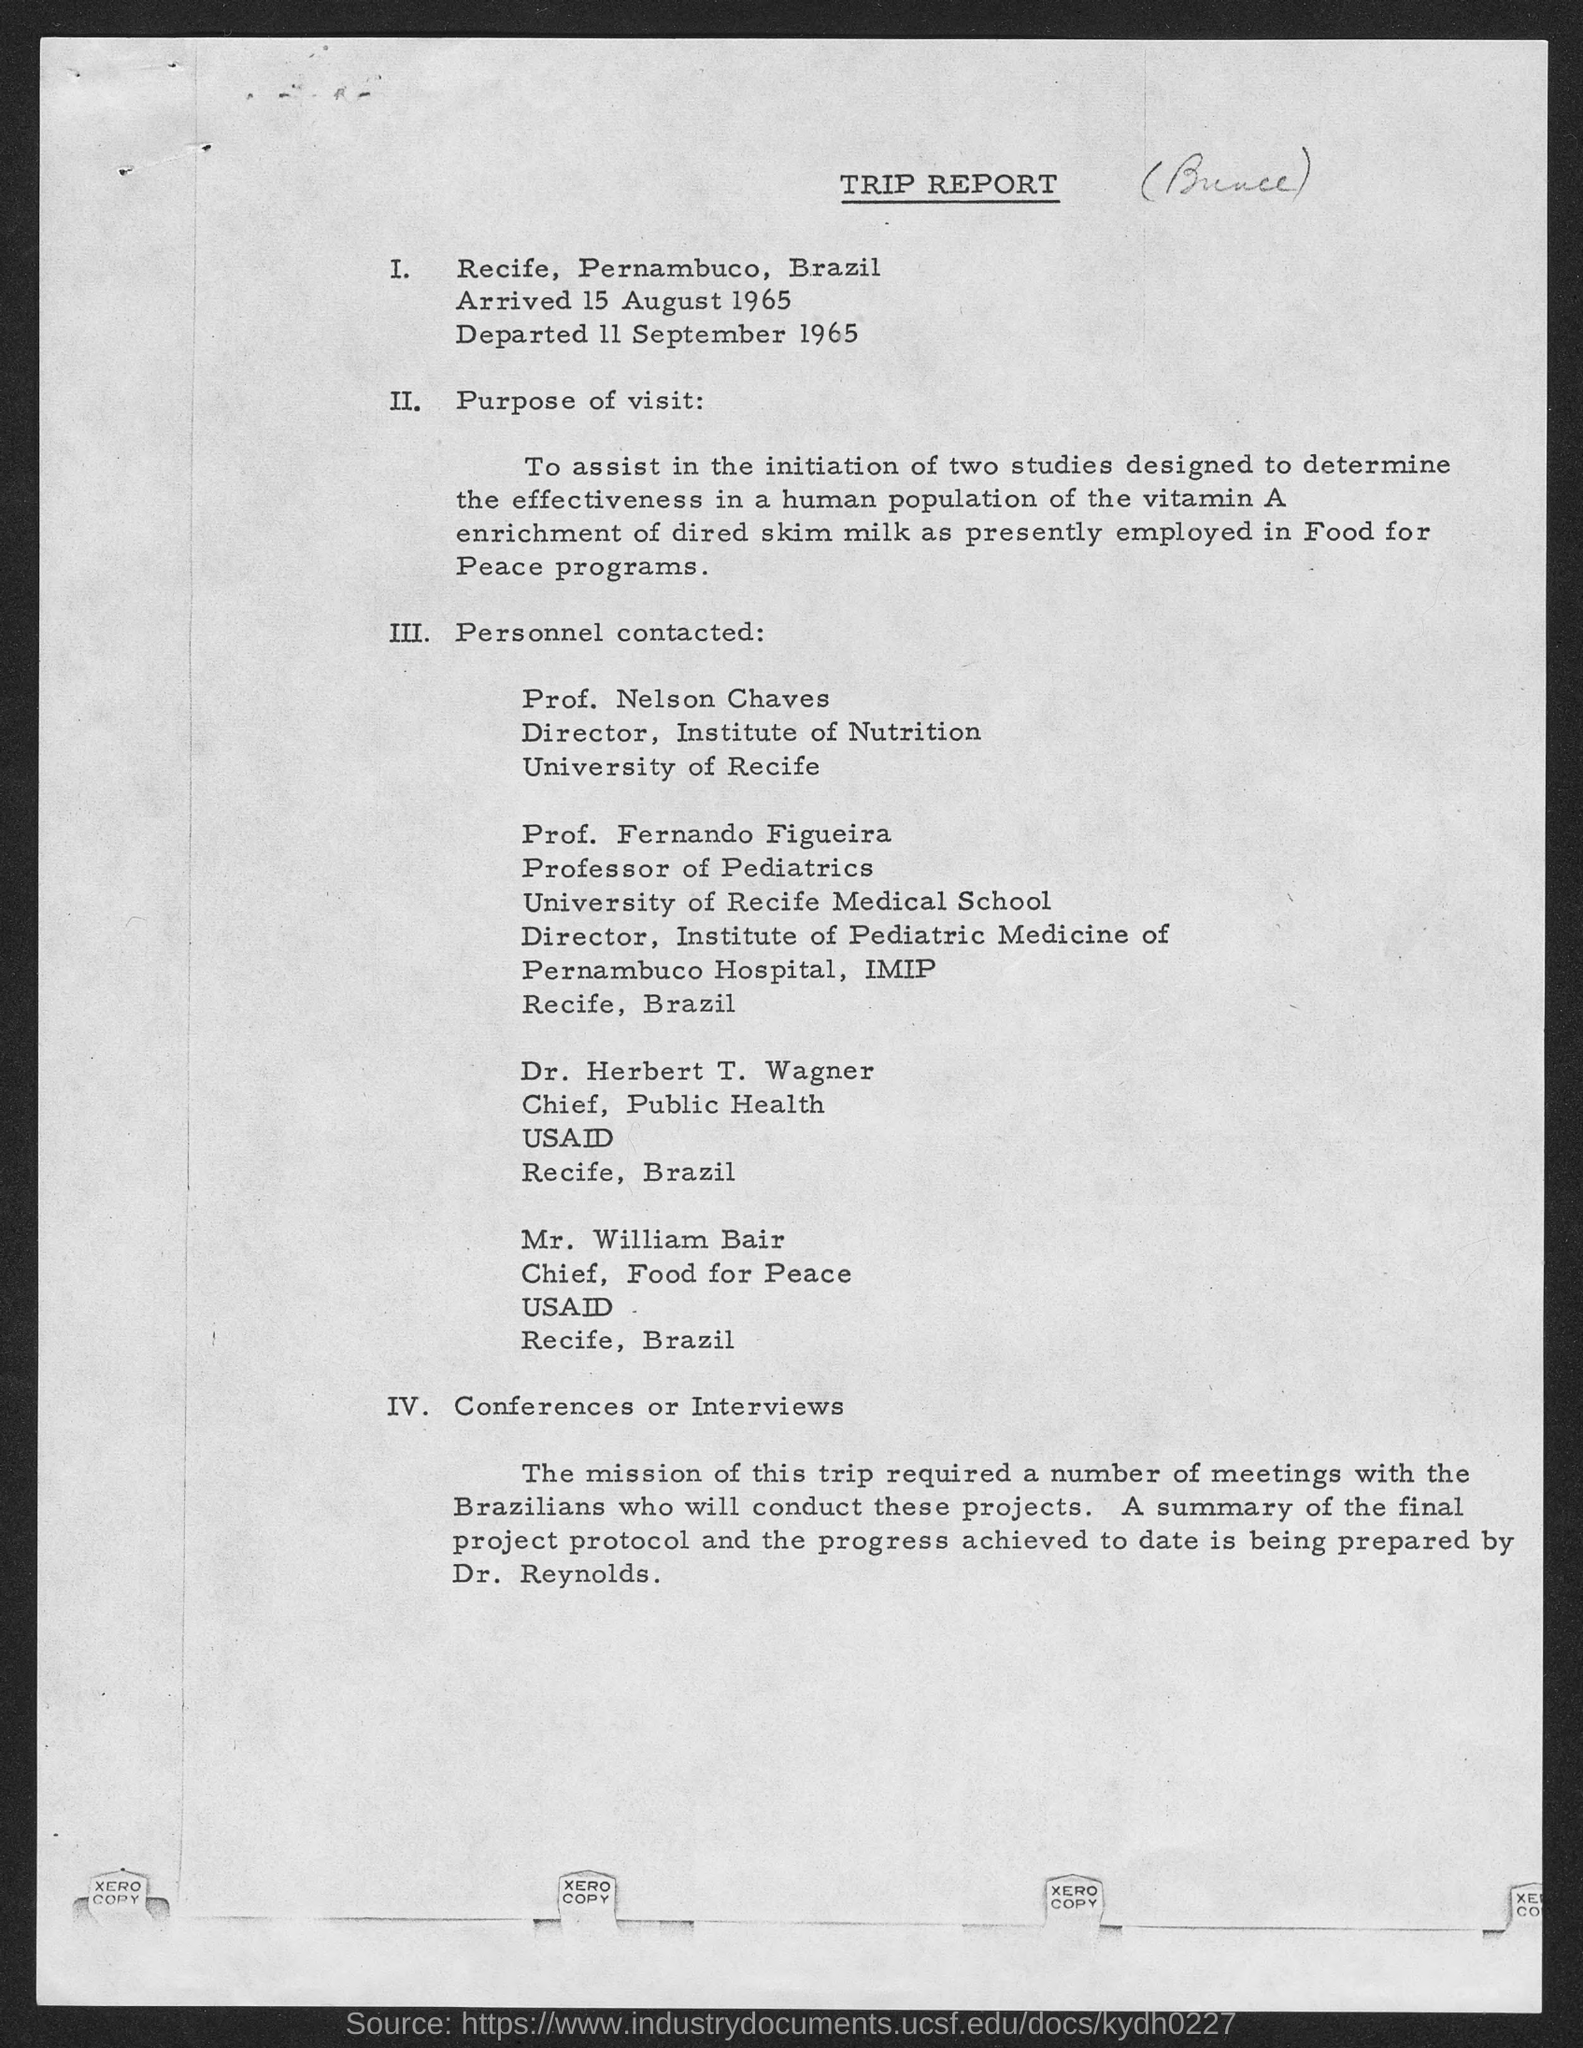What is the name of the report?
Make the answer very short. TRIP REPORT. What is the position of prof. nelson chaves ?
Offer a terse response. Director. What is the position of prof. fernando figueira ?
Your answer should be compact. Professor of Pediatrics. What is the position of dr. herbert t. wagner ?
Your answer should be very brief. Chief. What is the position of mr. william bair ?
Give a very brief answer. Chief, Food for Peace. 